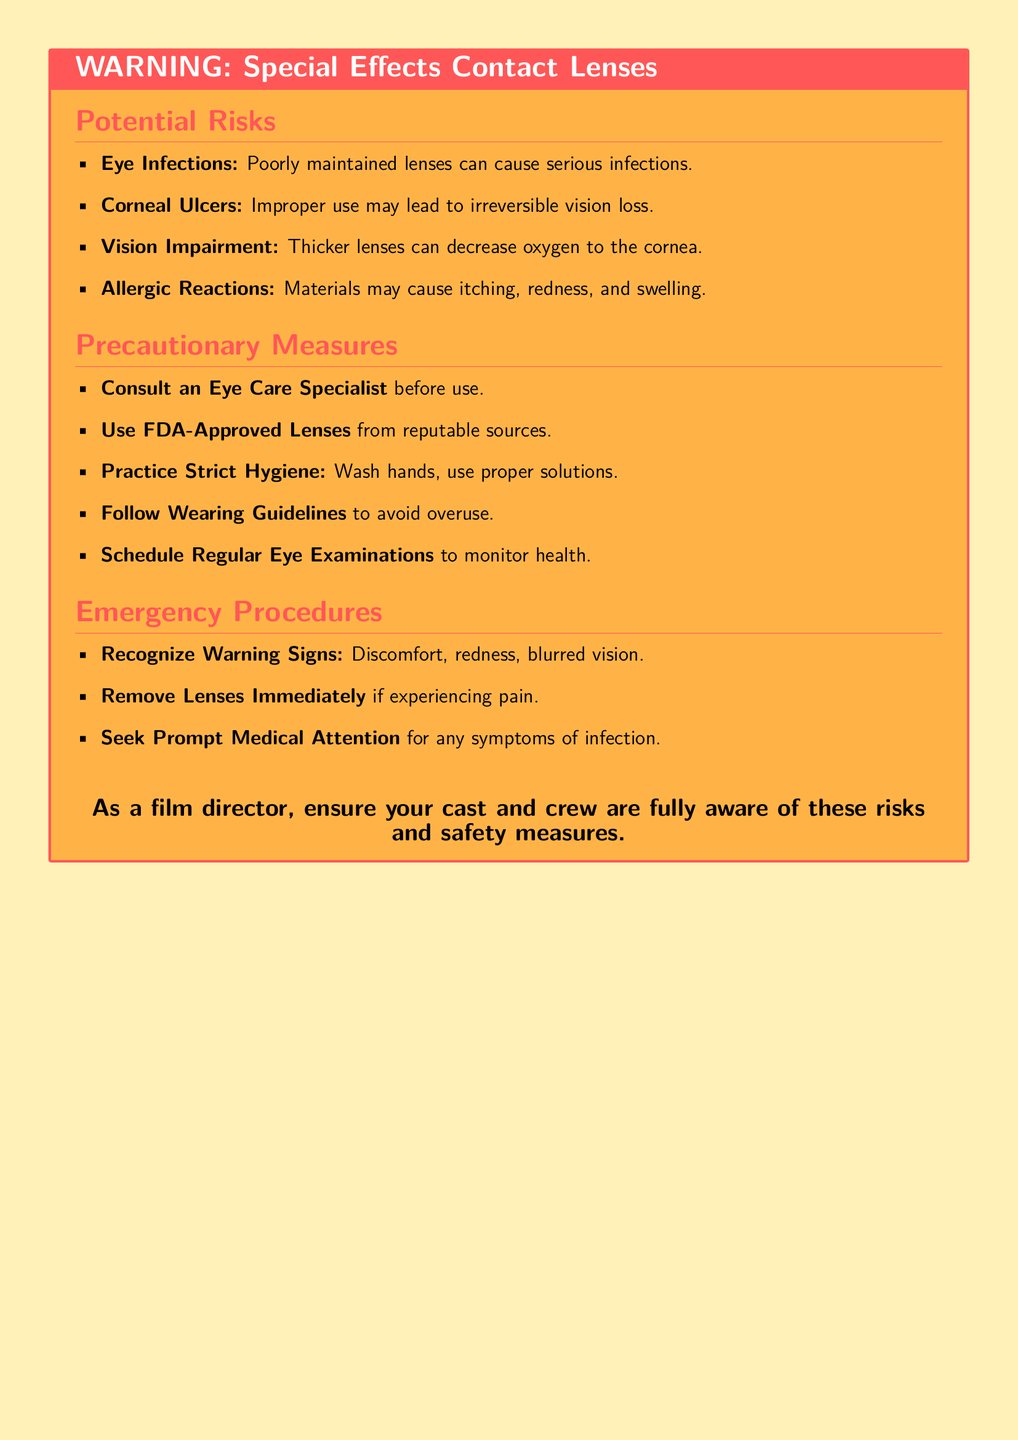What are the potential risks of using special effects contact lenses? The document lists specific risks associated with the lenses, including eye infections, corneal ulcers, vision impairment, and allergic reactions.
Answer: Eye infections, corneal ulcers, vision impairment, allergic reactions What should be done before using special effects contact lenses? The precautionary measures highlight the importance of consulting a professional before use.
Answer: Consult an Eye Care Specialist What symptoms indicate a need to remove the lenses immediately? The document outlines certain discomforts like pain that necessitate lens removal.
Answer: Pain What is stated about the maintenance of lenses? The potential risks emphasize that poorly maintained lenses can lead to serious infections.
Answer: Poor maintenance can cause infections How many precautionary measures are listed in the document? There are several precautionary measures enumerated in the document.
Answer: Five What is recommended for dealing with allergic reactions? The document does not specify treatment but highlights attention to symptoms like itching and redness.
Answer: No specific treatment mentioned What color is the title of the warning? The title color is defined in the document and is visually highlighted.
Answer: Warning Red What should one do if experiencing blurred vision? The document advises seeking medical attention for symptoms like blurred vision.
Answer: Seek Prompt Medical Attention 